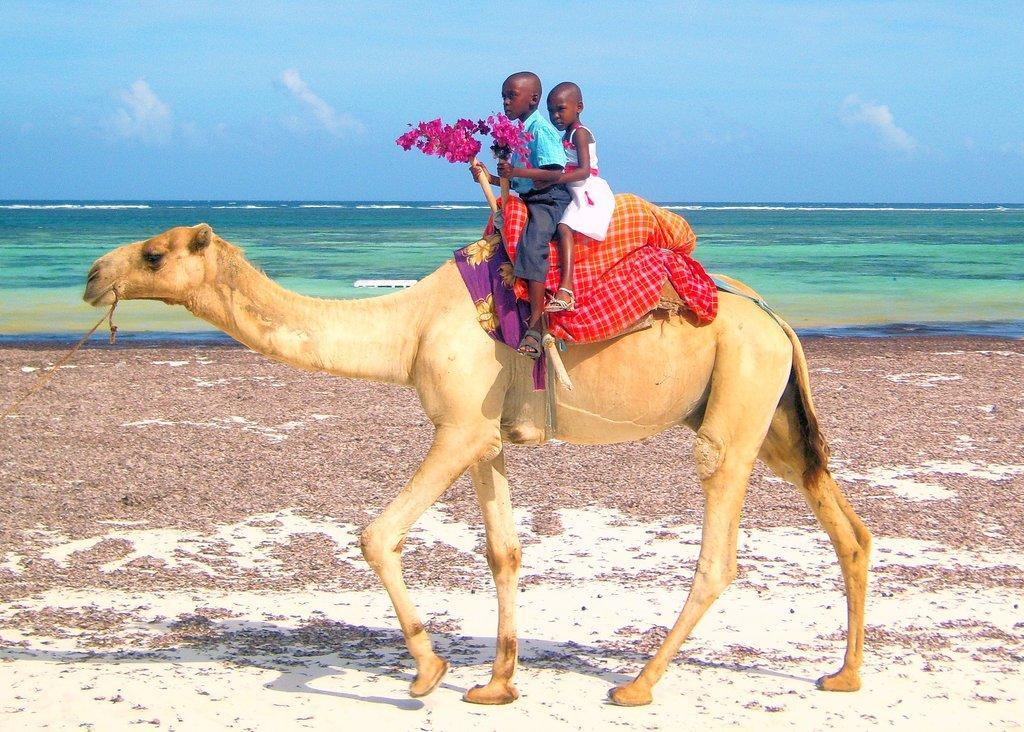How would you summarize this image in a sentence or two? In this image there is a camel walking on the ground. There are two kids sitting on the camel. A boy is holding flowers in his hand. Behind the camel where is the water. At the top there is the sky. 